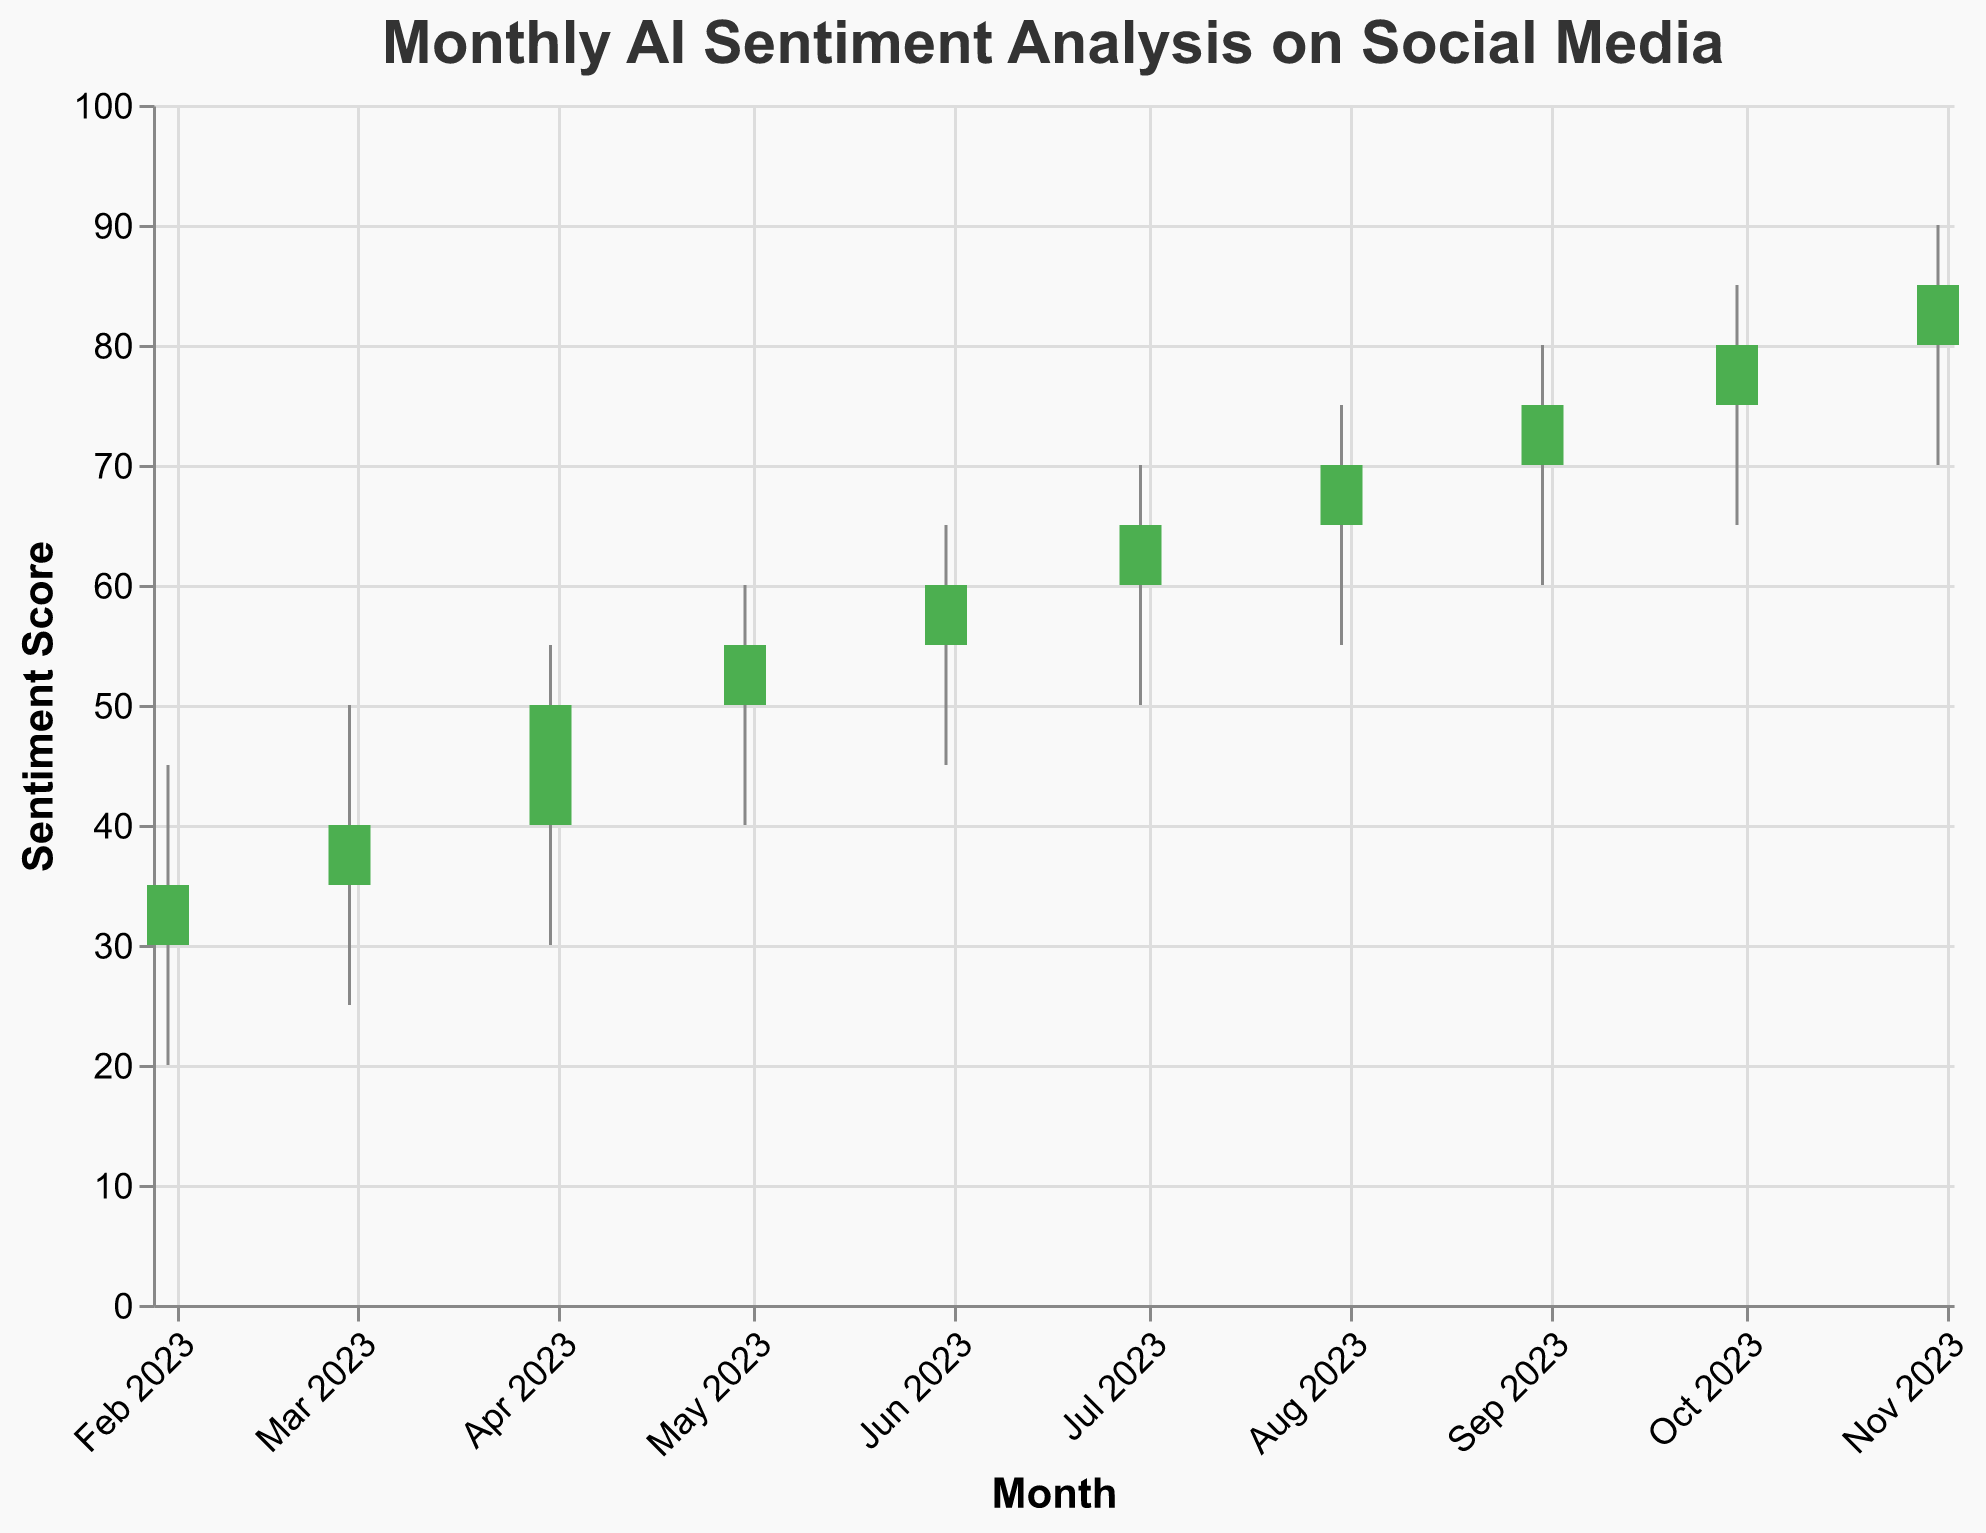What is the title of the figure? The title is displayed at the top of the figure in a larger font size. It provides a summary of what the chart represents: "Monthly AI Sentiment Analysis on Social Media"
Answer: Monthly AI Sentiment Analysis on Social Media How many months of data are represented in the figure? Each candlestick represents one month, and there are data points for each month from January 2023 to October 2023. By counting these, we find there are 10 months in total.
Answer: 10 During which month was the highest sentiment (high value) recorded? Look at the "High" value for each month. The highest "High" value is 90, which occurred in October 2023.
Answer: October 2023 In which months did the sentiment score close higher than it opened? For each month, compare the "Close" value to the "Open" value. The months where "Close" > "Open" are January, February, March, April, May, June, July, August, September, and October 2023.
Answer: All months from January to October 2023 What's the difference between the highest and lowest sentiment scores in July 2023? Subtract the lowest value (55) from the highest value (75) in July 2023. The difference is 75 - 55 = 20.
Answer: 20 Between which two consecutive months was the increase in "Close" value the greatest? Calculate the difference in "Close" values between consecutive months. Check all values:
  - February-March: 50 - 40 = 10
  - March-April: 55 - 50 = 5
  - April-May: 60 - 55 = 5
  - May-June: 65 - 60 = 5
  - June-July: 70 - 65 = 5
  - July-August: 75 - 70 = 5
  - August-September: 80 - 75 = 5
  - September-October: 85 - 80 = 5
The greatest increase is between February and March, with an increase of 10.
Answer: February to March Which month had the lowest "Open" sentiment score? Look at the "Open" values for each month and identify the lowest value. The lowest "Open" value is 30 in January 2023.
Answer: January 2023 What was the average "Close" sentiment score across all ten months? Summing up "Close" values for all months: 35 + 40 + 50 + 55 + 60 + 65 + 70 + 75 + 80 + 85 = 615. Divide by 10 (number of months) to get the average: 615 / 10 = 61.5.
Answer: 61.5 Which month had the widest range of sentiment scores? Calculate the range (High - Low) for each month:
  - January: 45 - 20 = 25
  - February: 50 - 25 = 25
  - March: 55 - 30 = 25
  - April: 60 - 40 = 20
  - May: 65 - 45 = 20
  - June: 70 - 50 = 20
  - July: 75 - 55 = 20
  - August: 80 - 60 = 20
  - September: 85 - 65 = 20
  - October: 90 - 70 = 20
January, February, and March all had the widest range of 25.
Answer: January, February, and March 